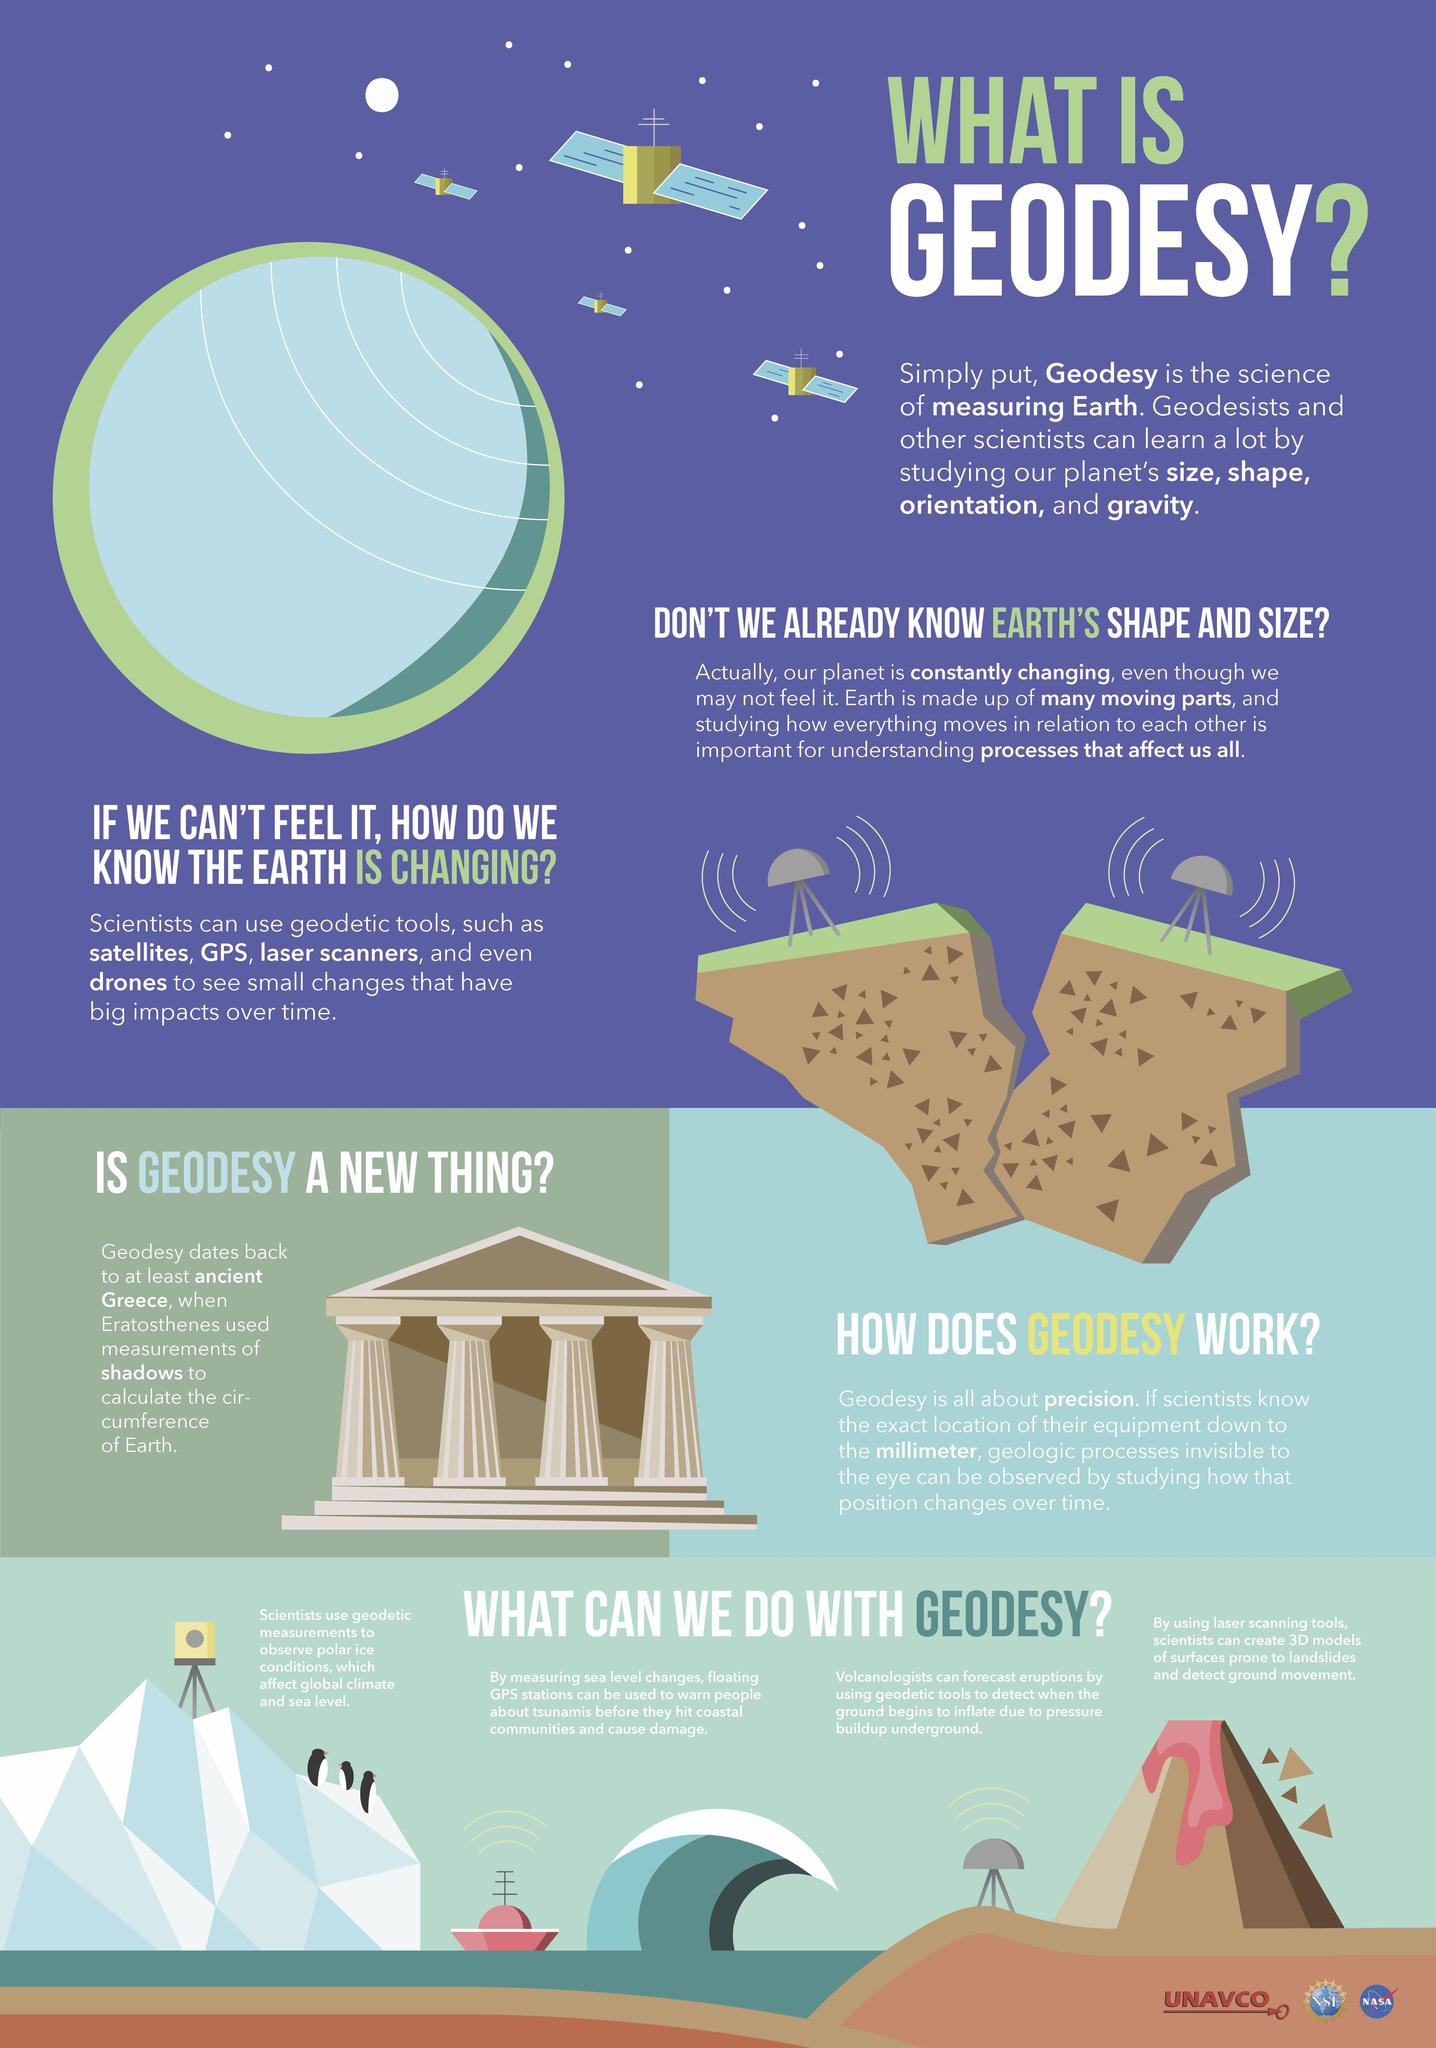How many satellites are in this infographic?
Answer the question with a short phrase. 4 